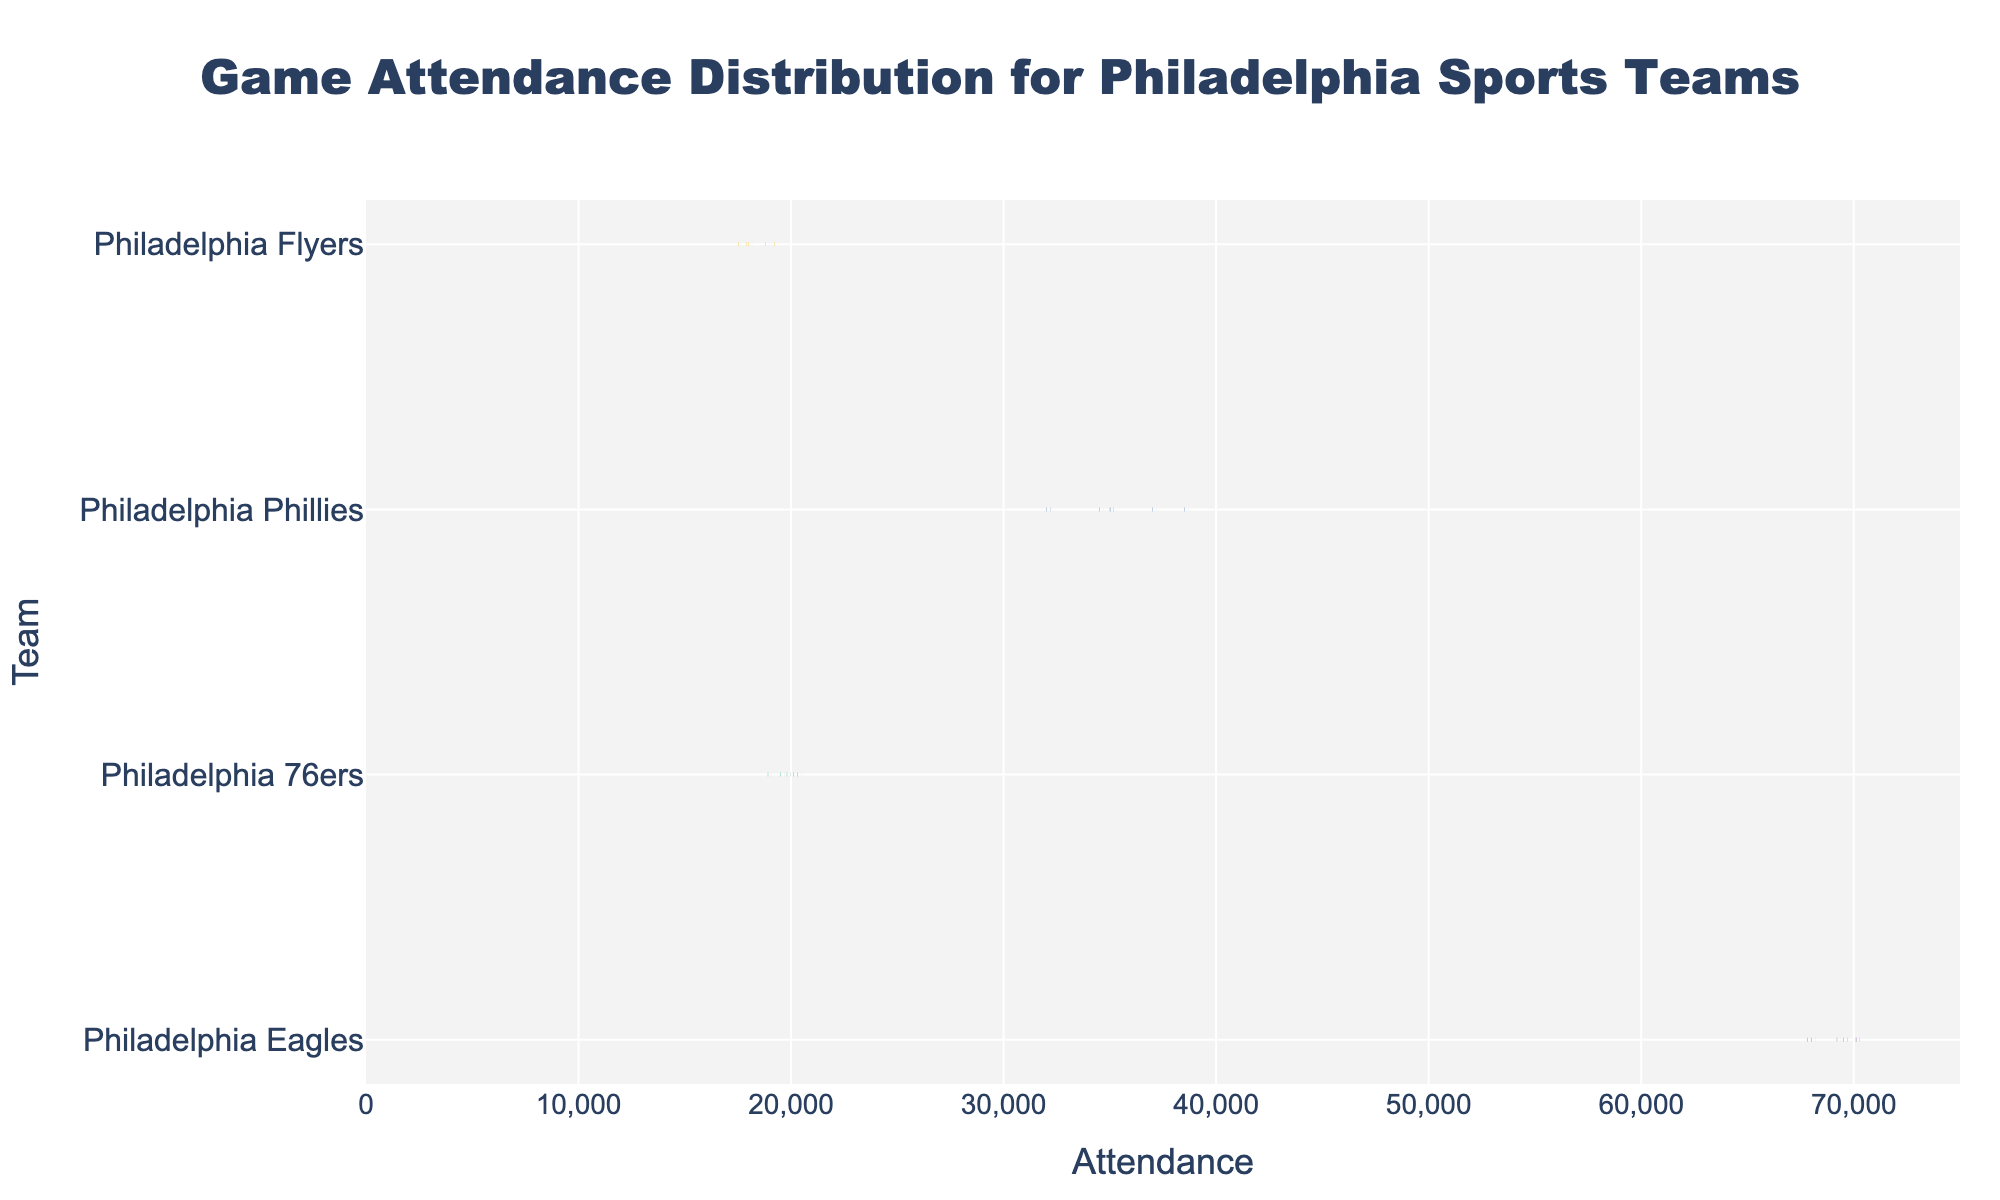What's the title of the plot? The title is displayed at the top of the figure. It reads "Game Attendance Distribution for Philadelphia Sports Teams".
Answer: Game Attendance Distribution for Philadelphia Sports Teams Which team has the highest average attendance? The plot shows the density plots with a mean line for each team. The Philadelphia Eagles have the highest mean attendance, which can be seen by the position of their mean line further to the right compared to other teams.
Answer: Philadelphia Eagles How does the attendance distribution of Philadelphia 76ers compare to the Philadelphia Flyers? We look at the density plots of both teams. The Philadelphia 76ers have a higher median attendance, as their mean line is to the right of the Flyers'. Additionally, the range of attendance is slightly higher for the 76ers compared to the Flyers.
Answer: 76ers have higher median What is the approximate range of attendance for the Philadelphia Phillies? From the plot, we can observe the range of the density plot for the Philadelphia Phillies. The attendance ranges from about 32,000 to 38,500.
Answer: 32,000 to 38,500 Which team has the smallest spread of attendance values? Spread can be observed by looking at the width of the density plots. The Philadelphia Flyers appear to have the smallest spread since their attendance values are tightly clustered around their mean line.
Answer: Philadelphia Flyers Is the mean attendance of the Philadelphia Eagles above 65,000? The mean line for the Philadelphia Eagles on the density plot is clearly above the 65,000 mark.
Answer: Yes How many data points are there for the Philadelphia Eagles? By referring to the data points mentioned under the Philadelphia Eagles, we count each data point used in the density plot. There are five data points for the Eagles.
Answer: 5 Does any team have an attendance above 70,000? By looking at the density plots on the x-axis, we can see that the Philadelphia Eagles have attendances above 70,000 as part of their distribution.
Answer: Yes What's the difference between the highest attendance of the Philadelphia Flyers and the lowest attendance of the Philadelphia 76ers? The highest attendance of the Philadelphia Flyers is 19,200 and the lowest attendance of the Philadelphia 76ers is 18,900. The difference is calculated as 19,200 - 18,900.
Answer: 300 Which team's attendance data is closely packed around the median? The closeness of data around the median can be judged by the width around the mean lines of density plots. The Philadelphia Flyers have a tightly packed distribution around their median compared to other teams.
Answer: Philadelphia Flyers 